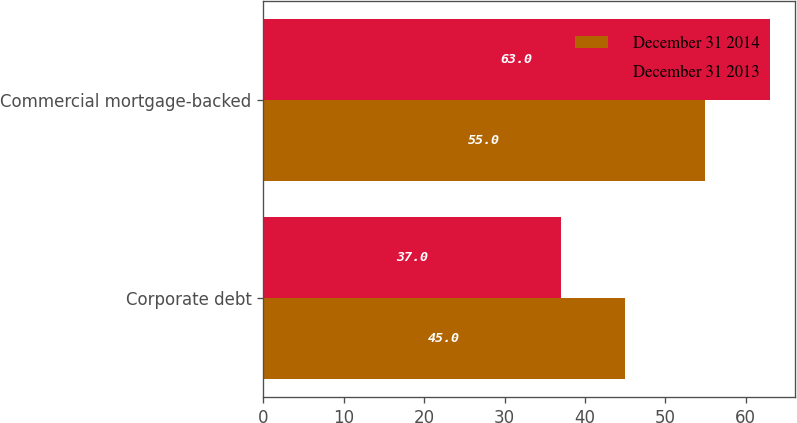Convert chart to OTSL. <chart><loc_0><loc_0><loc_500><loc_500><stacked_bar_chart><ecel><fcel>Corporate debt<fcel>Commercial mortgage-backed<nl><fcel>December 31 2014<fcel>45<fcel>55<nl><fcel>December 31 2013<fcel>37<fcel>63<nl></chart> 